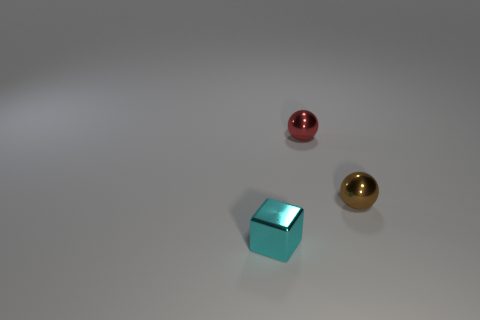Add 1 small yellow blocks. How many objects exist? 4 Subtract all cubes. How many objects are left? 2 Add 2 metallic spheres. How many metallic spheres exist? 4 Subtract 0 green balls. How many objects are left? 3 Subtract all big red rubber cylinders. Subtract all tiny cyan shiny things. How many objects are left? 2 Add 3 cyan metal things. How many cyan metal things are left? 4 